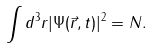Convert formula to latex. <formula><loc_0><loc_0><loc_500><loc_500>\int d ^ { 3 } r | \Psi ( \vec { r } , t ) | ^ { 2 } = N .</formula> 